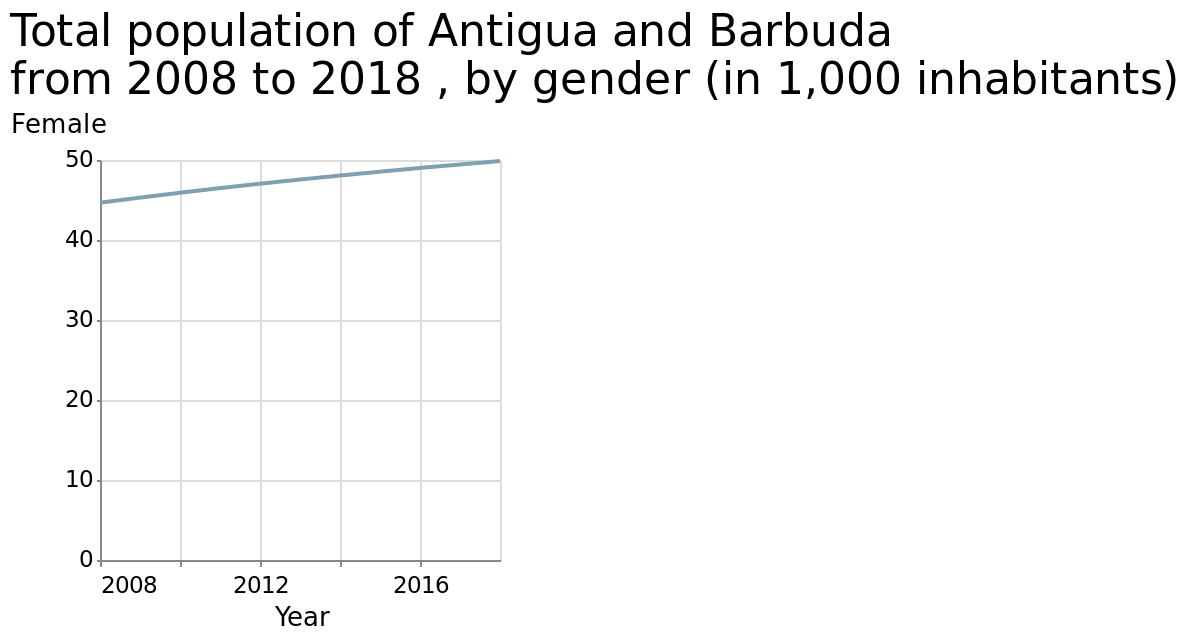<image>
What was the change in female population per 1000 in Antigua and Barbuda from 2008 to 2018? The female population per 1000 in Antigua and Barbuda increased by 5 from 2008 to 2018. Did the female population per 1000 in Antigua and Barbuda decrease by 5 from 2008 to 2018? No.The female population per 1000 in Antigua and Barbuda increased by 5 from 2008 to 2018. 